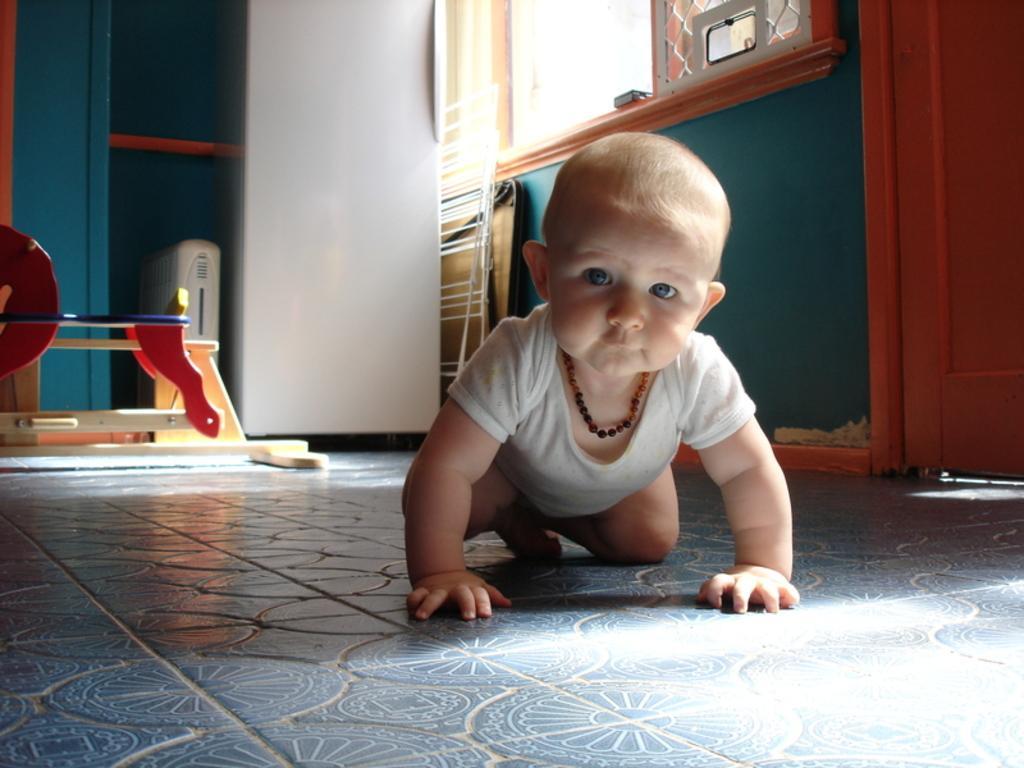Can you describe this image briefly? In the picture I can see a baby is crawling on the floor. In the background I can see a wall, windows and some other objects. 